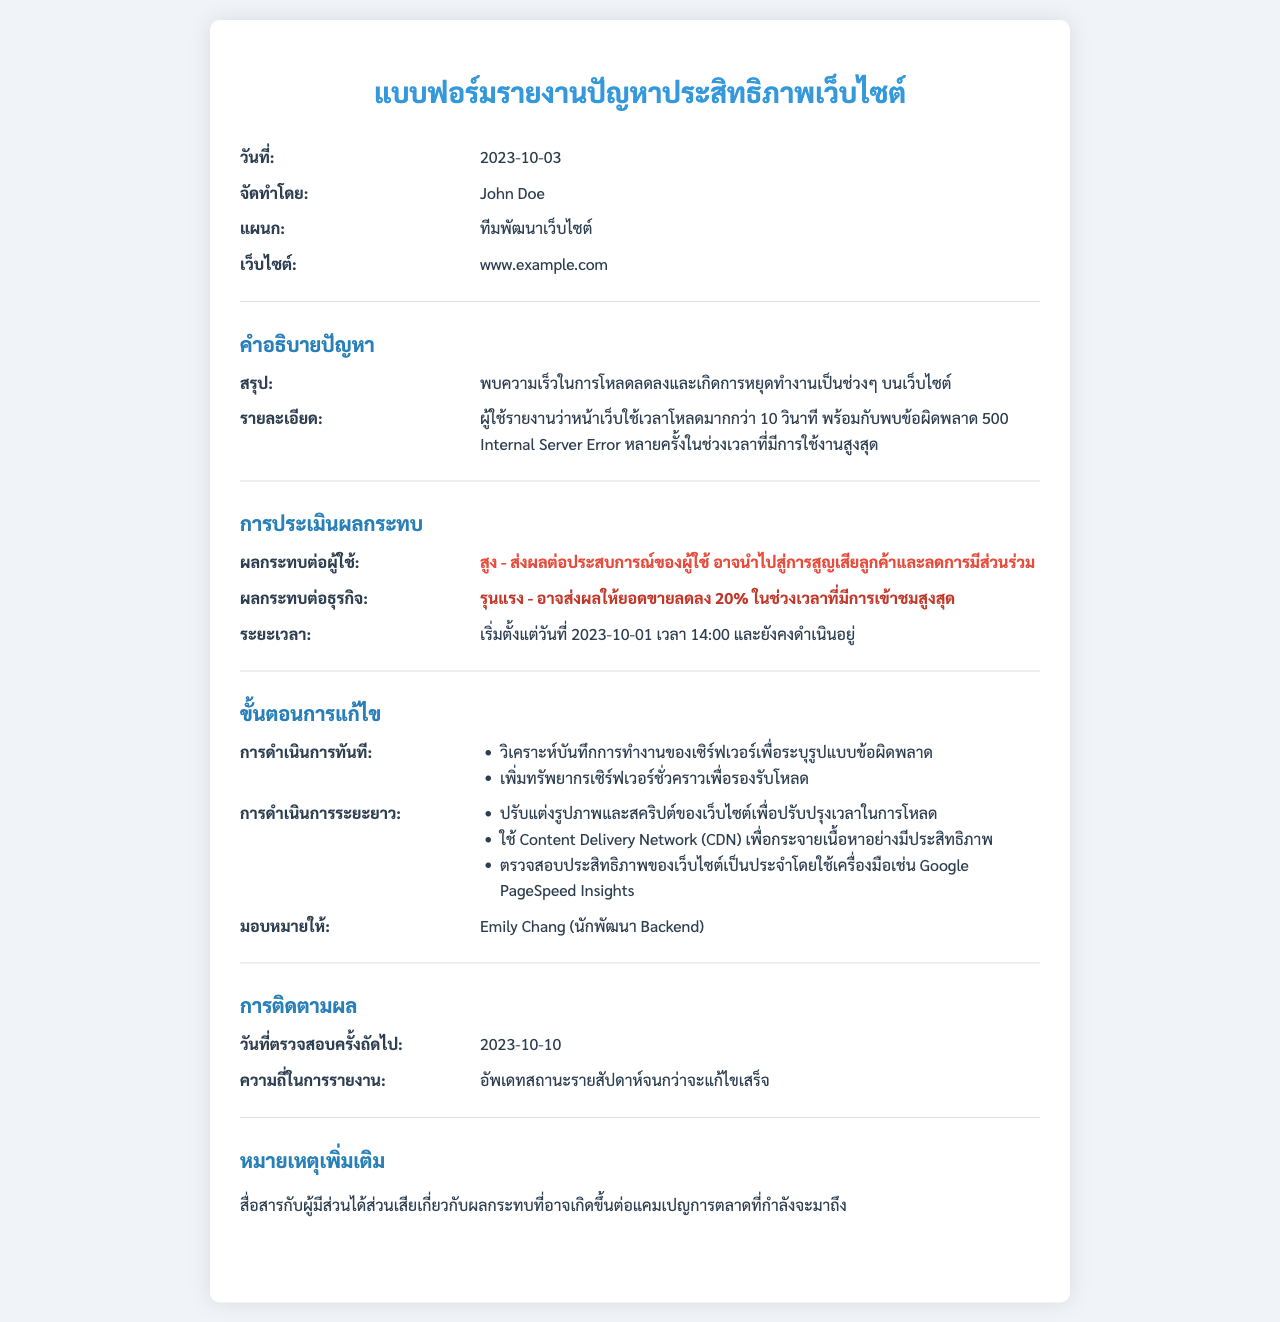What is the date of the report? The date of the report is mentioned in the document as the date of creation.
Answer: 2023-10-03 Who prepared the report? The document specifies the name of the person who prepared the report.
Answer: John Doe What is the website mentioned? The document lists the specific website related to the performance issues.
Answer: www.example.com What is the summary of the problem? The summary of the problem is given in the description of the issue section.
Answer: พบความเร็วในการโหลดลดลงและเกิดการหยุดทำงานเป็นช่วงๆ บนเว็บไซต์ What is the impact on users? The impact on users is detailed in the impact assessment section of the document.
Answer: สูง - ส่งผลต่อประสบการณ์ของผู้ใช้ อาจนำไปสู่การสูญเสียลูกค้าและลดการมีส่วนร่วม What is the immediate action taken? The immediate actions are mentioned in the resolution steps of the document.
Answer: วิเคราะห์บันทึกการทำงานของเซิร์ฟเวอร์เพื่อระบุรูปแบบข้อผิดพลาด Who is assigned to resolve the issue? The report specifies the name of the individual assigned to handle the issue.
Answer: Emily Chang What is the next review date? The document states when the next follow-up is scheduled to take place.
Answer: 2023-10-10 What is noted as an additional remark? The document contains a section for extra remarks which are specified in the last part.
Answer: สื่อสารกับผู้มีส่วนได้ส่วนเสียเกี่ยวกับผลกระทบที่อาจเกิดขึ้นต่อแคมเปญการตลาดที่กำลังจะมาถึง 